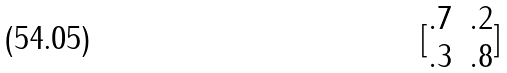<formula> <loc_0><loc_0><loc_500><loc_500>[ \begin{matrix} . 7 & . 2 \\ . 3 & . 8 \end{matrix} ]</formula> 